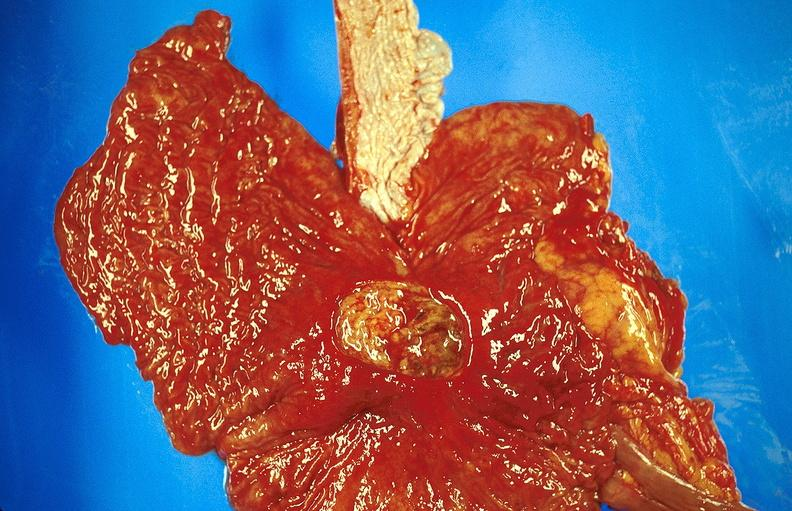where does this belong to?
Answer the question using a single word or phrase. Gastrointestinal system 